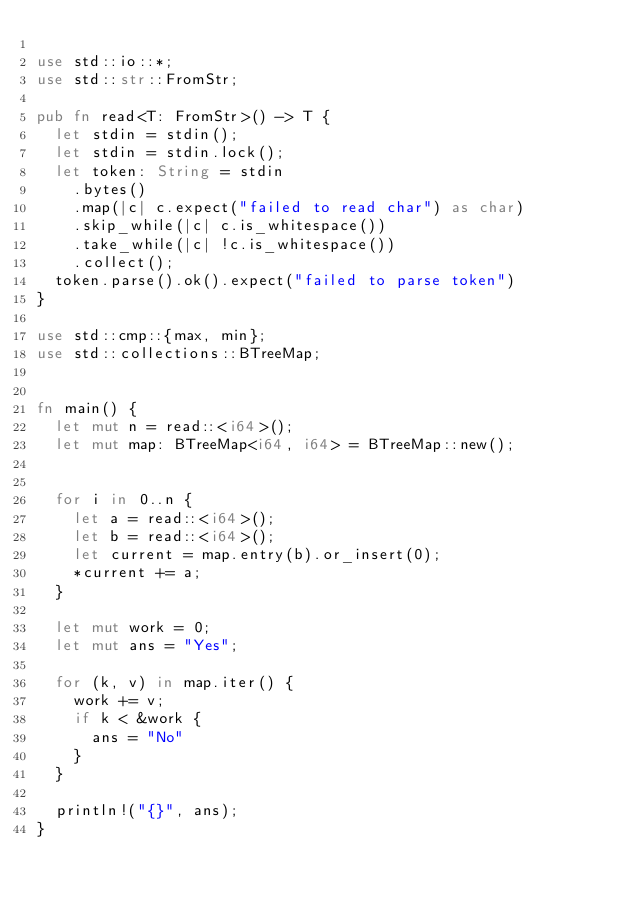<code> <loc_0><loc_0><loc_500><loc_500><_Rust_>
use std::io::*;
use std::str::FromStr;

pub fn read<T: FromStr>() -> T {
  let stdin = stdin();
  let stdin = stdin.lock();
  let token: String = stdin
    .bytes()
    .map(|c| c.expect("failed to read char") as char)
    .skip_while(|c| c.is_whitespace())
    .take_while(|c| !c.is_whitespace())
    .collect();
  token.parse().ok().expect("failed to parse token")
}

use std::cmp::{max, min};
use std::collections::BTreeMap;


fn main() {
  let mut n = read::<i64>();
  let mut map: BTreeMap<i64, i64> = BTreeMap::new();


  for i in 0..n {
    let a = read::<i64>();
    let b = read::<i64>();
    let current = map.entry(b).or_insert(0);
    *current += a;
  }

  let mut work = 0;
  let mut ans = "Yes";

  for (k, v) in map.iter() {
    work += v;
    if k < &work {
      ans = "No"
    }
  }

  println!("{}", ans);
}
</code> 